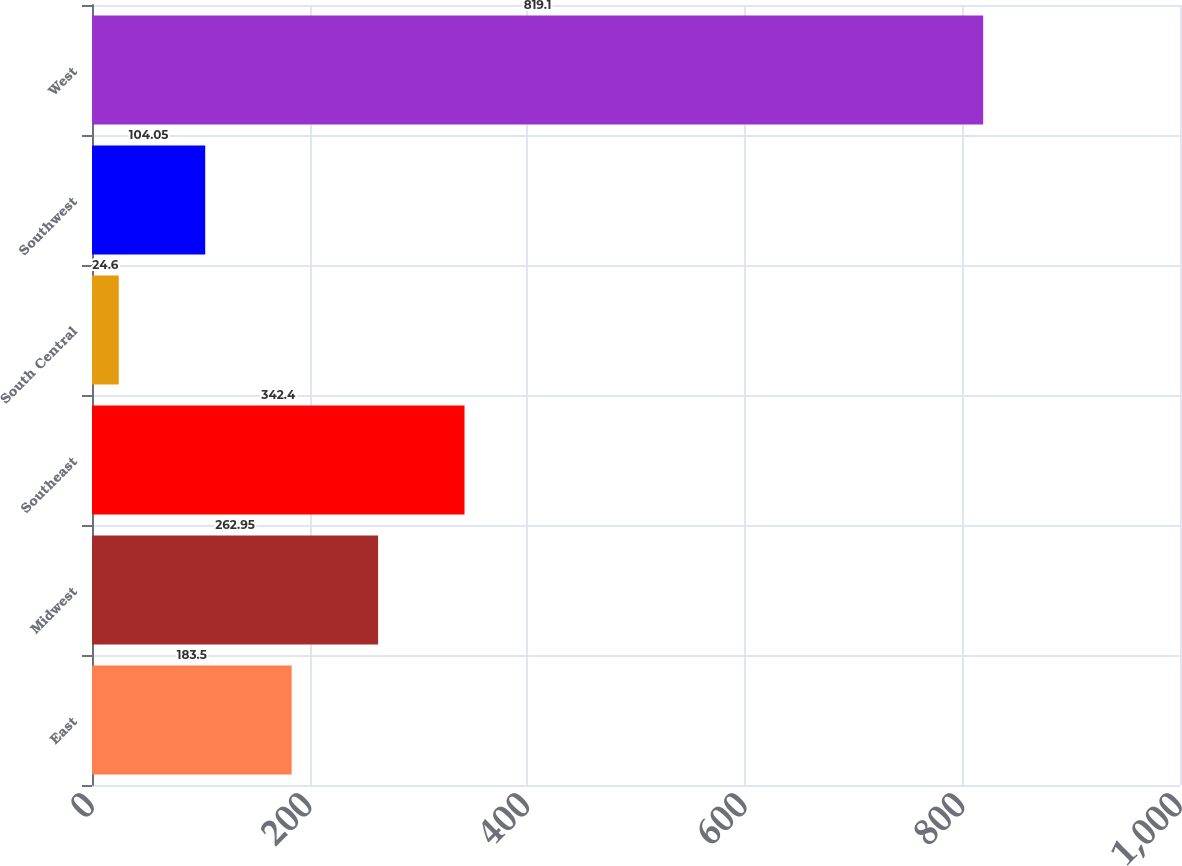<chart> <loc_0><loc_0><loc_500><loc_500><bar_chart><fcel>East<fcel>Midwest<fcel>Southeast<fcel>South Central<fcel>Southwest<fcel>West<nl><fcel>183.5<fcel>262.95<fcel>342.4<fcel>24.6<fcel>104.05<fcel>819.1<nl></chart> 